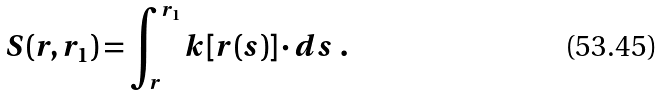Convert formula to latex. <formula><loc_0><loc_0><loc_500><loc_500>S ( { r } , { r } _ { 1 } ) = \int _ { r } ^ { { r } _ { 1 } } { k } [ { r } ( s ) ] \cdot d { s } \ .</formula> 